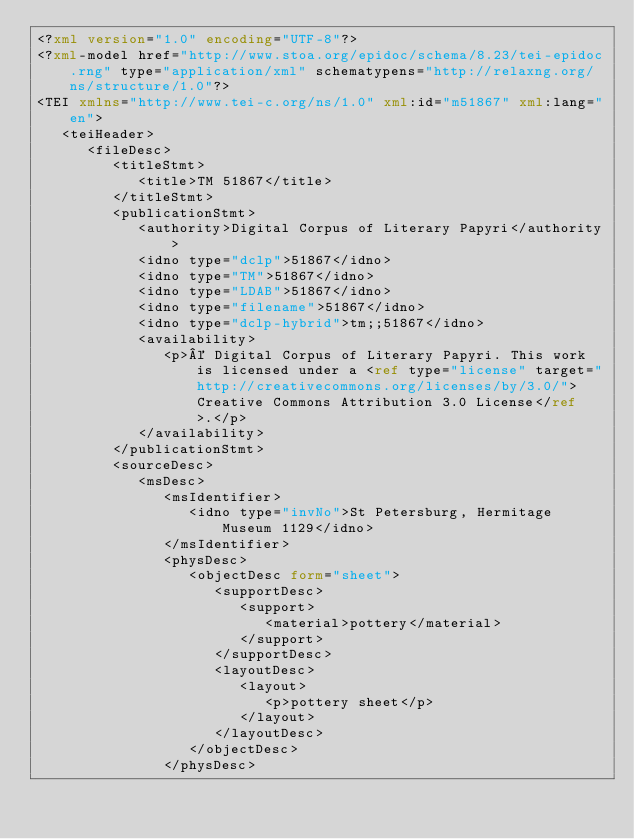<code> <loc_0><loc_0><loc_500><loc_500><_XML_><?xml version="1.0" encoding="UTF-8"?>
<?xml-model href="http://www.stoa.org/epidoc/schema/8.23/tei-epidoc.rng" type="application/xml" schematypens="http://relaxng.org/ns/structure/1.0"?>
<TEI xmlns="http://www.tei-c.org/ns/1.0" xml:id="m51867" xml:lang="en">
   <teiHeader>
      <fileDesc>
         <titleStmt>
            <title>TM 51867</title>
         </titleStmt>
         <publicationStmt>
            <authority>Digital Corpus of Literary Papyri</authority>
            <idno type="dclp">51867</idno>
            <idno type="TM">51867</idno>
            <idno type="LDAB">51867</idno>
            <idno type="filename">51867</idno>
            <idno type="dclp-hybrid">tm;;51867</idno>
            <availability>
               <p>© Digital Corpus of Literary Papyri. This work is licensed under a <ref type="license" target="http://creativecommons.org/licenses/by/3.0/">Creative Commons Attribution 3.0 License</ref>.</p>
            </availability>
         </publicationStmt>
         <sourceDesc>
            <msDesc>
               <msIdentifier>
                  <idno type="invNo">St Petersburg, Hermitage Museum 1129</idno>
               </msIdentifier>
               <physDesc>
                  <objectDesc form="sheet">
                     <supportDesc>
                        <support>
                           <material>pottery</material>
                        </support>
                     </supportDesc>
                     <layoutDesc>
                        <layout>
                           <p>pottery sheet</p>
                        </layout>
                     </layoutDesc>
                  </objectDesc>
               </physDesc></code> 